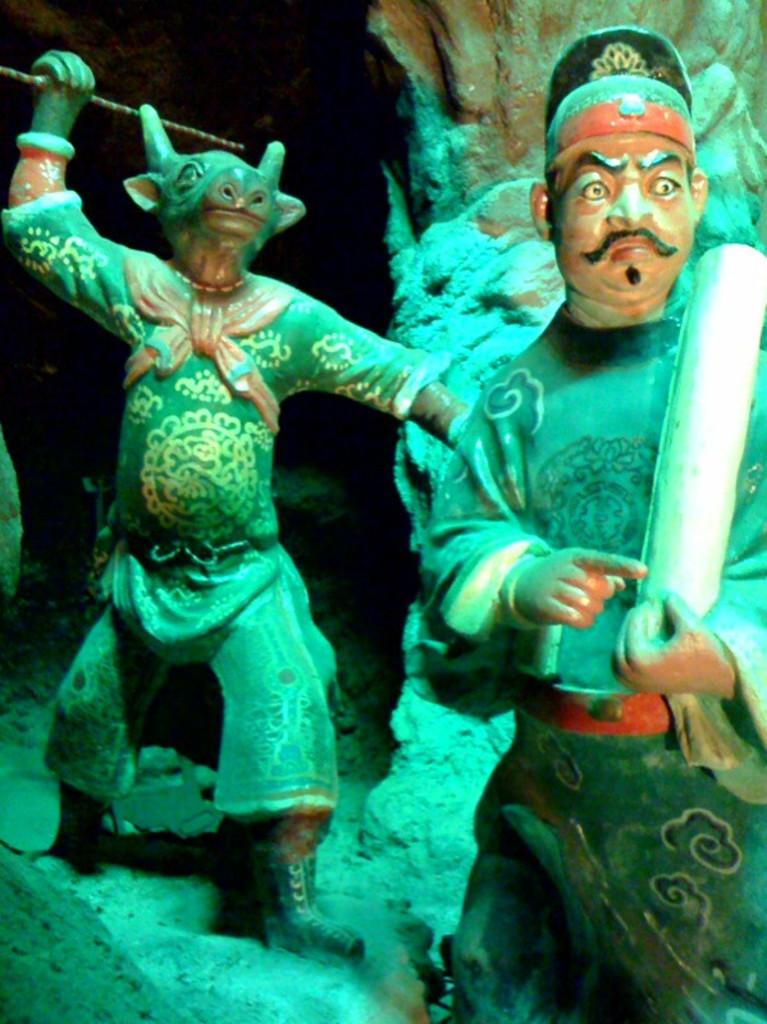What objects are present in the image? There are statues in the image. What can be observed about the background of the image? The background of the image is dark. What type of roof can be seen on top of the statues in the image? There is no roof present in the image, as it features statues with a dark background. Can you tell me how many toads are sitting on the statues in the image? There are no toads present in the image; it only features statues. 